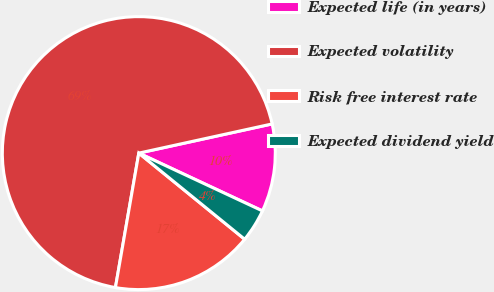Convert chart. <chart><loc_0><loc_0><loc_500><loc_500><pie_chart><fcel>Expected life (in years)<fcel>Expected volatility<fcel>Risk free interest rate<fcel>Expected dividend yield<nl><fcel>10.39%<fcel>68.83%<fcel>16.87%<fcel>3.91%<nl></chart> 